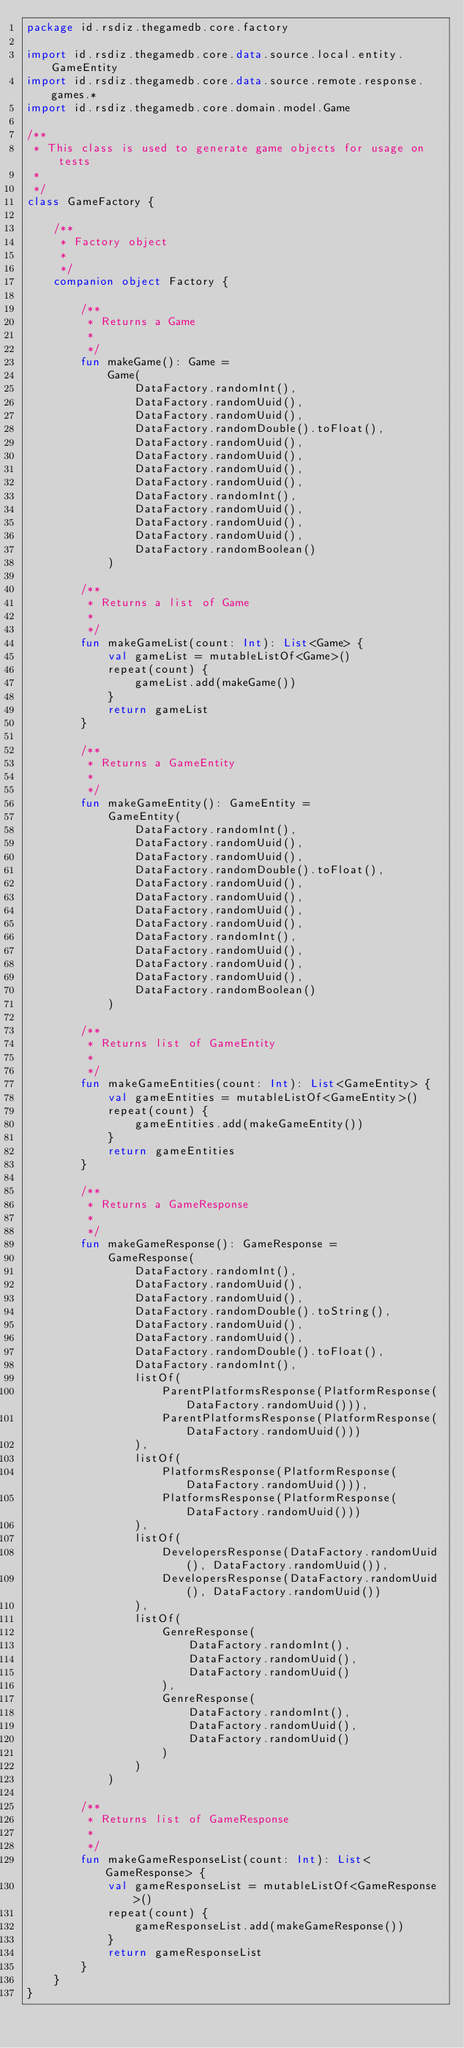Convert code to text. <code><loc_0><loc_0><loc_500><loc_500><_Kotlin_>package id.rsdiz.thegamedb.core.factory

import id.rsdiz.thegamedb.core.data.source.local.entity.GameEntity
import id.rsdiz.thegamedb.core.data.source.remote.response.games.*
import id.rsdiz.thegamedb.core.domain.model.Game

/**
 * This class is used to generate game objects for usage on tests
 *
 */
class GameFactory {

    /**
     * Factory object
     *
     */
    companion object Factory {

        /**
         * Returns a Game
         *
         */
        fun makeGame(): Game =
            Game(
                DataFactory.randomInt(),
                DataFactory.randomUuid(),
                DataFactory.randomUuid(),
                DataFactory.randomDouble().toFloat(),
                DataFactory.randomUuid(),
                DataFactory.randomUuid(),
                DataFactory.randomUuid(),
                DataFactory.randomUuid(),
                DataFactory.randomInt(),
                DataFactory.randomUuid(),
                DataFactory.randomUuid(),
                DataFactory.randomUuid(),
                DataFactory.randomBoolean()
            )

        /**
         * Returns a list of Game
         *
         */
        fun makeGameList(count: Int): List<Game> {
            val gameList = mutableListOf<Game>()
            repeat(count) {
                gameList.add(makeGame())
            }
            return gameList
        }

        /**
         * Returns a GameEntity
         *
         */
        fun makeGameEntity(): GameEntity =
            GameEntity(
                DataFactory.randomInt(),
                DataFactory.randomUuid(),
                DataFactory.randomUuid(),
                DataFactory.randomDouble().toFloat(),
                DataFactory.randomUuid(),
                DataFactory.randomUuid(),
                DataFactory.randomUuid(),
                DataFactory.randomUuid(),
                DataFactory.randomInt(),
                DataFactory.randomUuid(),
                DataFactory.randomUuid(),
                DataFactory.randomUuid(),
                DataFactory.randomBoolean()
            )

        /**
         * Returns list of GameEntity
         *
         */
        fun makeGameEntities(count: Int): List<GameEntity> {
            val gameEntities = mutableListOf<GameEntity>()
            repeat(count) {
                gameEntities.add(makeGameEntity())
            }
            return gameEntities
        }

        /**
         * Returns a GameResponse
         *
         */
        fun makeGameResponse(): GameResponse =
            GameResponse(
                DataFactory.randomInt(),
                DataFactory.randomUuid(),
                DataFactory.randomUuid(),
                DataFactory.randomDouble().toString(),
                DataFactory.randomUuid(),
                DataFactory.randomUuid(),
                DataFactory.randomDouble().toFloat(),
                DataFactory.randomInt(),
                listOf(
                    ParentPlatformsResponse(PlatformResponse(DataFactory.randomUuid())),
                    ParentPlatformsResponse(PlatformResponse(DataFactory.randomUuid()))
                ),
                listOf(
                    PlatformsResponse(PlatformResponse(DataFactory.randomUuid())),
                    PlatformsResponse(PlatformResponse(DataFactory.randomUuid()))
                ),
                listOf(
                    DevelopersResponse(DataFactory.randomUuid(), DataFactory.randomUuid()),
                    DevelopersResponse(DataFactory.randomUuid(), DataFactory.randomUuid())
                ),
                listOf(
                    GenreResponse(
                        DataFactory.randomInt(),
                        DataFactory.randomUuid(),
                        DataFactory.randomUuid()
                    ),
                    GenreResponse(
                        DataFactory.randomInt(),
                        DataFactory.randomUuid(),
                        DataFactory.randomUuid()
                    )
                )
            )

        /**
         * Returns list of GameResponse
         *
         */
        fun makeGameResponseList(count: Int): List<GameResponse> {
            val gameResponseList = mutableListOf<GameResponse>()
            repeat(count) {
                gameResponseList.add(makeGameResponse())
            }
            return gameResponseList
        }
    }
}
</code> 